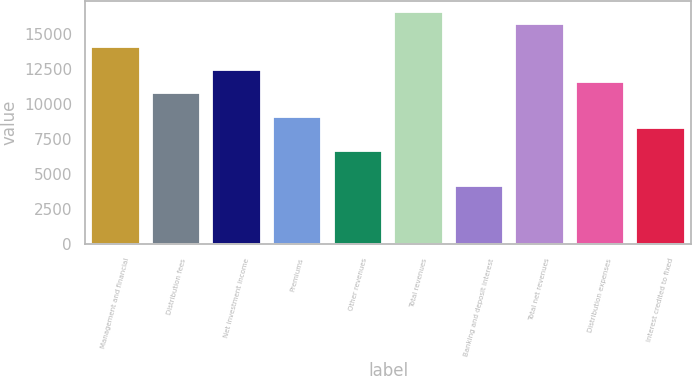<chart> <loc_0><loc_0><loc_500><loc_500><bar_chart><fcel>Management and financial<fcel>Distribution fees<fcel>Net investment income<fcel>Premiums<fcel>Other revenues<fcel>Total revenues<fcel>Banking and deposit interest<fcel>Total net revenues<fcel>Distribution expenses<fcel>Interest credited to fixed<nl><fcel>14060.5<fcel>10752.2<fcel>12406.3<fcel>9098.1<fcel>6616.92<fcel>16541.6<fcel>4135.74<fcel>15714.6<fcel>11579.3<fcel>8271.04<nl></chart> 